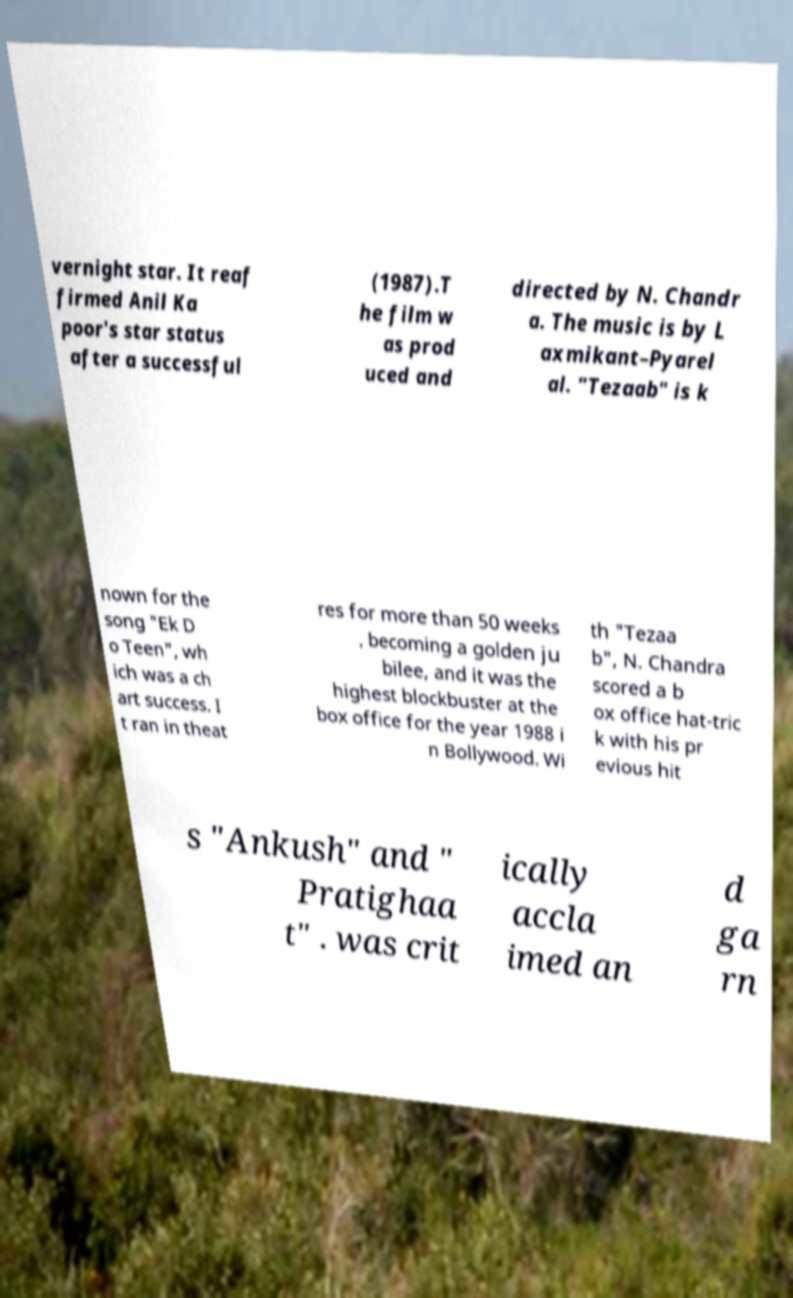Can you accurately transcribe the text from the provided image for me? vernight star. It reaf firmed Anil Ka poor's star status after a successful (1987).T he film w as prod uced and directed by N. Chandr a. The music is by L axmikant–Pyarel al. "Tezaab" is k nown for the song "Ek D o Teen", wh ich was a ch art success. I t ran in theat res for more than 50 weeks , becoming a golden ju bilee, and it was the highest blockbuster at the box office for the year 1988 i n Bollywood. Wi th "Tezaa b", N. Chandra scored a b ox office hat-tric k with his pr evious hit s "Ankush" and " Pratighaa t" . was crit ically accla imed an d ga rn 